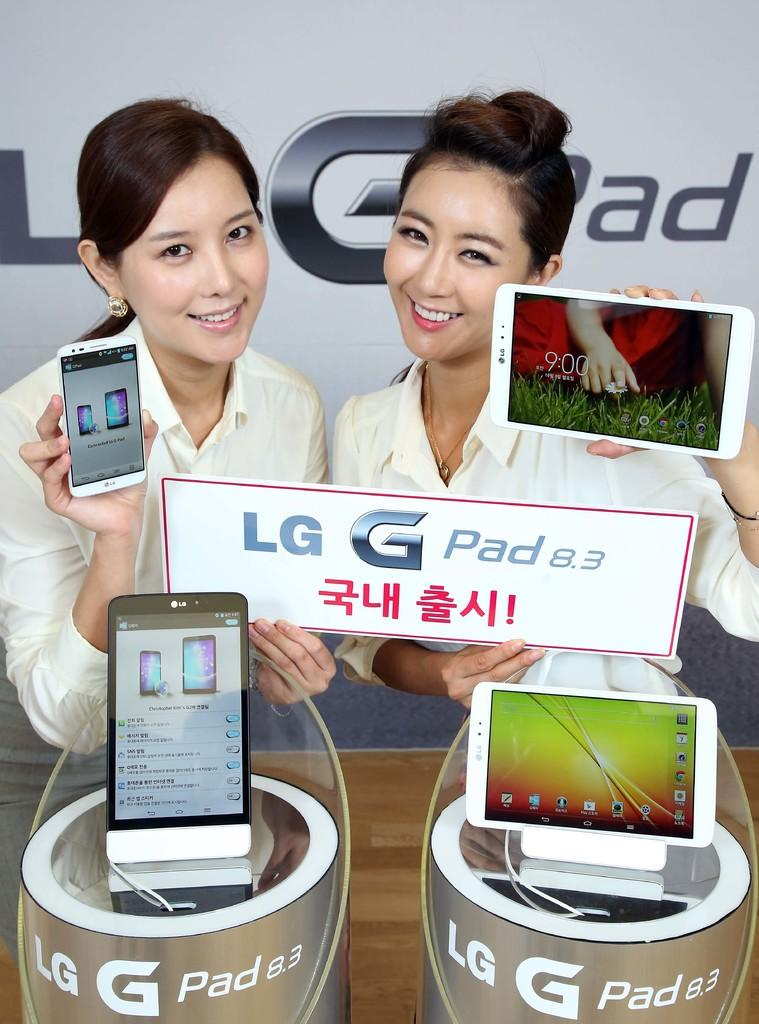<image>
Create a compact narrative representing the image presented. Two females holding electronics and a sign that says "LG G Pad". 